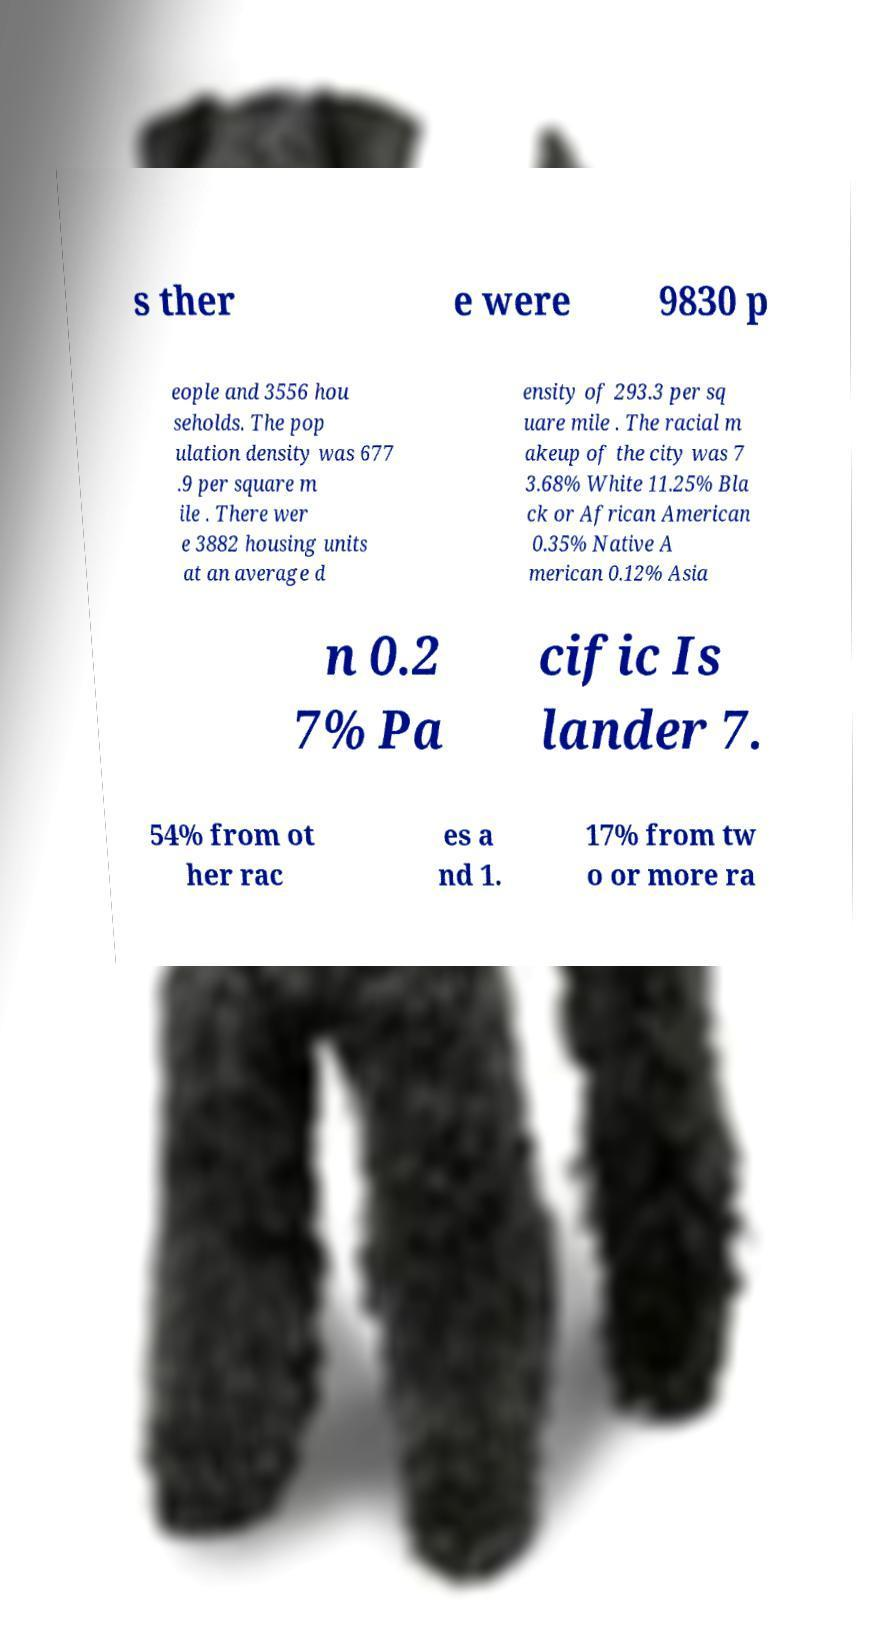Please identify and transcribe the text found in this image. s ther e were 9830 p eople and 3556 hou seholds. The pop ulation density was 677 .9 per square m ile . There wer e 3882 housing units at an average d ensity of 293.3 per sq uare mile . The racial m akeup of the city was 7 3.68% White 11.25% Bla ck or African American 0.35% Native A merican 0.12% Asia n 0.2 7% Pa cific Is lander 7. 54% from ot her rac es a nd 1. 17% from tw o or more ra 